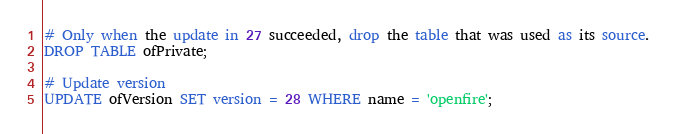<code> <loc_0><loc_0><loc_500><loc_500><_SQL_># Only when the update in 27 succeeded, drop the table that was used as its source.
DROP TABLE ofPrivate;

# Update version
UPDATE ofVersion SET version = 28 WHERE name = 'openfire';
</code> 